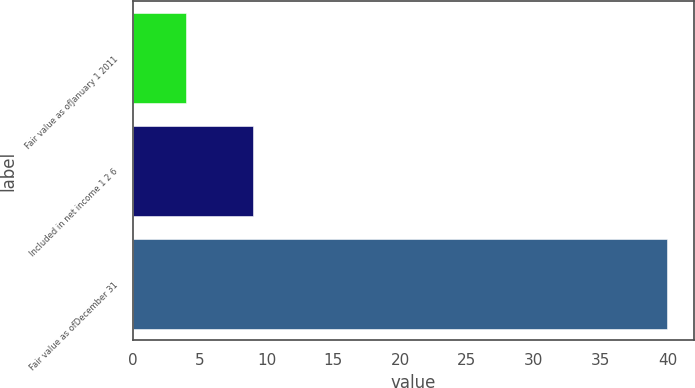Convert chart to OTSL. <chart><loc_0><loc_0><loc_500><loc_500><bar_chart><fcel>Fair value as ofJanuary 1 2011<fcel>Included in net income 1 2 6<fcel>Fair value as ofDecember 31<nl><fcel>4<fcel>9<fcel>40<nl></chart> 